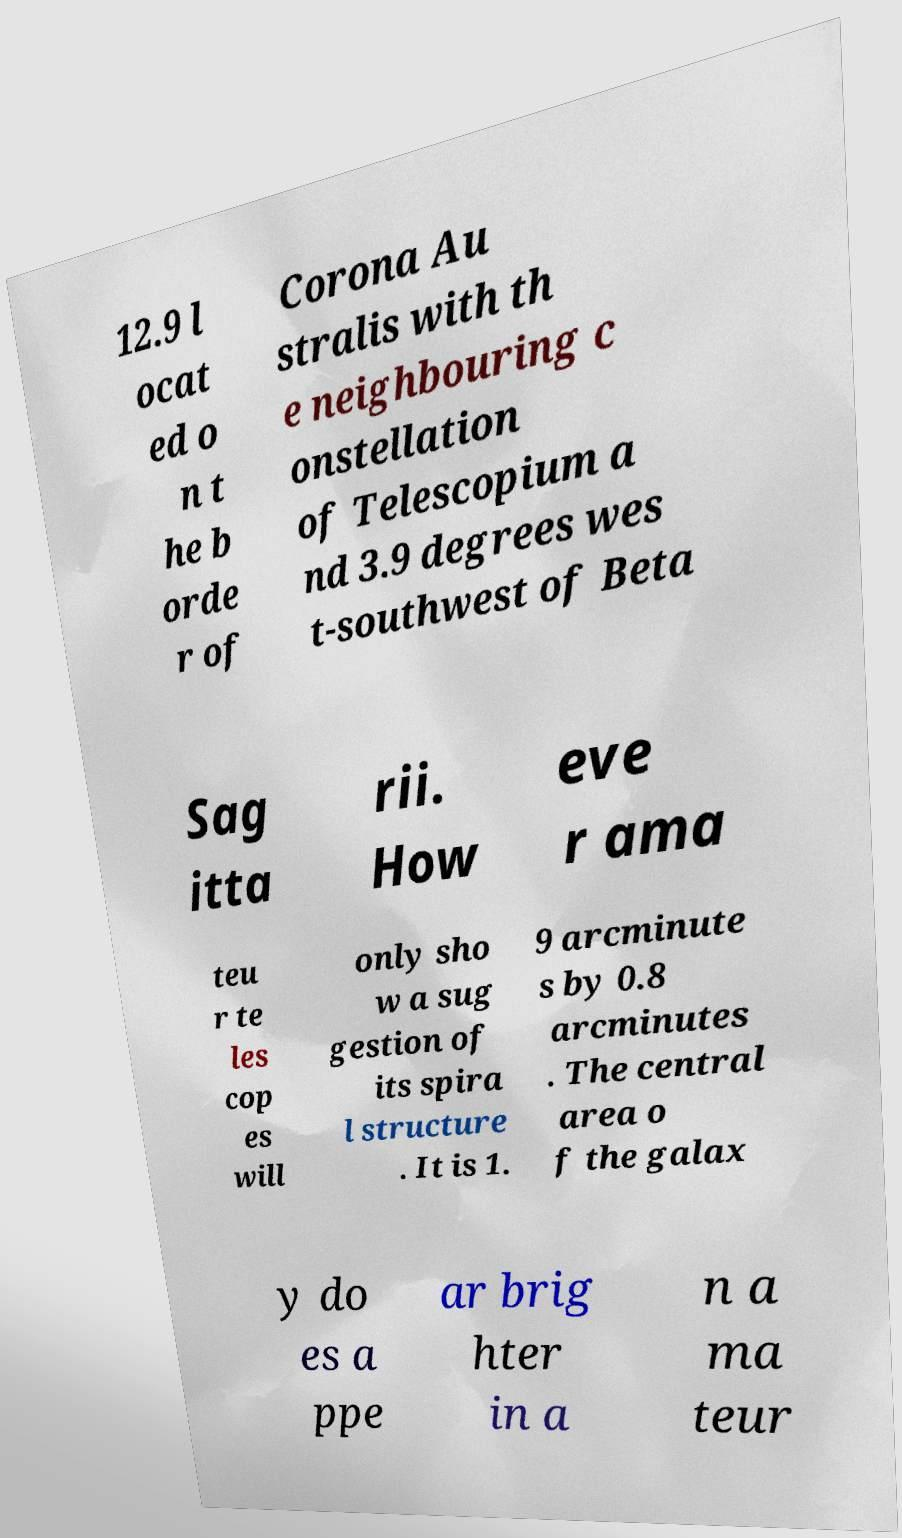Please read and relay the text visible in this image. What does it say? 12.9 l ocat ed o n t he b orde r of Corona Au stralis with th e neighbouring c onstellation of Telescopium a nd 3.9 degrees wes t-southwest of Beta Sag itta rii. How eve r ama teu r te les cop es will only sho w a sug gestion of its spira l structure . It is 1. 9 arcminute s by 0.8 arcminutes . The central area o f the galax y do es a ppe ar brig hter in a n a ma teur 